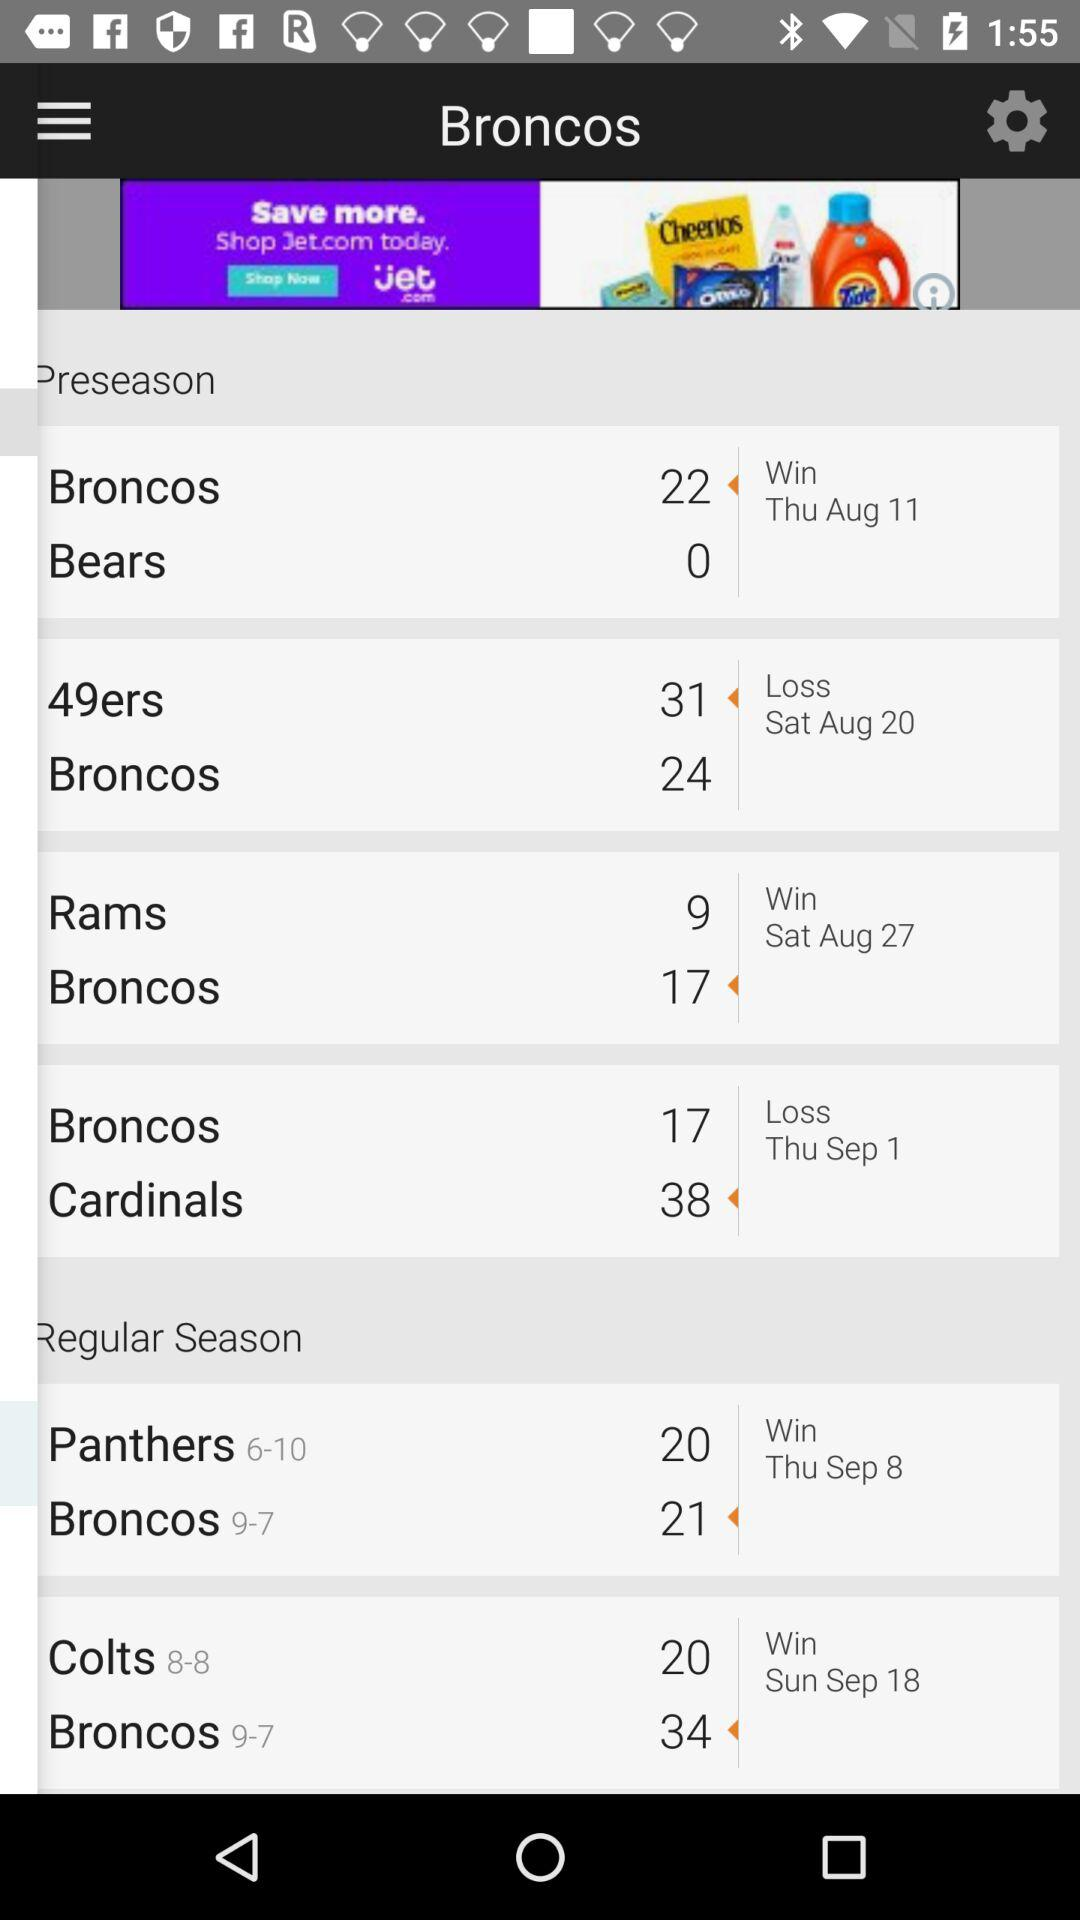Which team has the longest win streak, the Broncos or the Panthers?
Answer the question using a single word or phrase. Broncos 